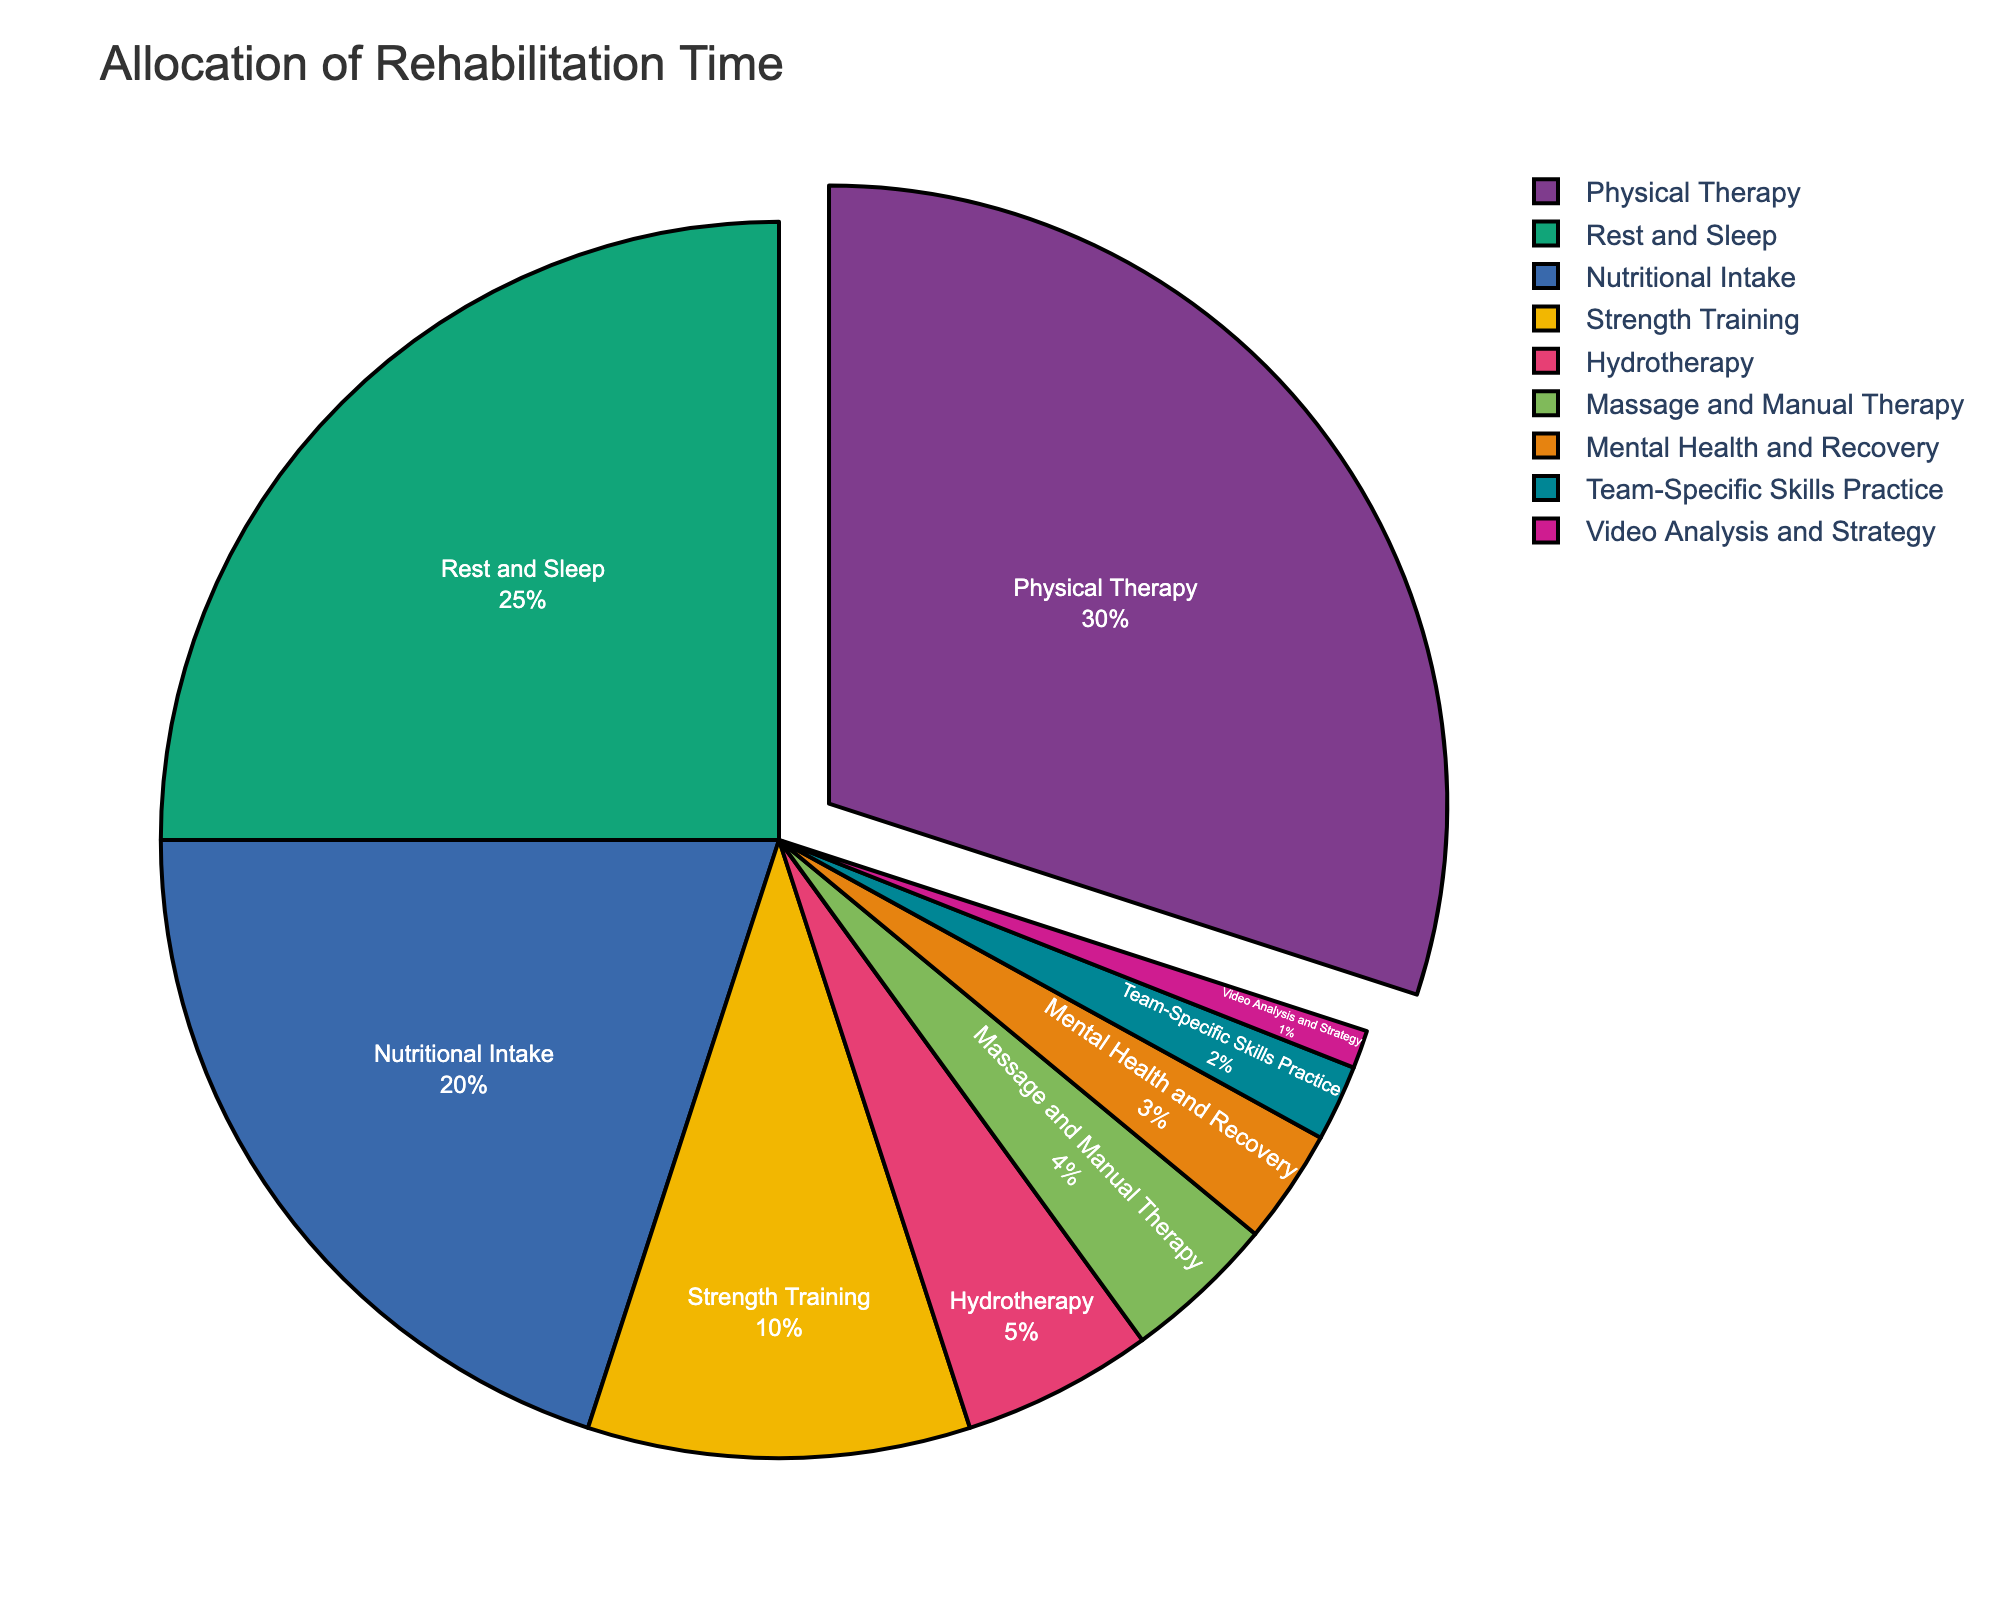How much more time is allocated to Physical Therapy compared to Strength Training? To determine how much more time is allocated to Physical Therapy compared to Strength Training, subtract the percentage for Strength Training from the percentage for Physical Therapy: 30% - 10% = 20%
Answer: 20% Which activity has the smallest allocation of rehabilitation time? To identify the activity with the smallest allocation of rehabilitation time, look for the activity with the smallest percentage in the pie chart. The smallest percentage is 1%, which corresponds to Video Analysis and Strategy.
Answer: Video Analysis and Strategy What percentage of the total rehabilitation time is dedicated to Rest and Sleep and Nutritional Intake combined? To find the combined percentage for Rest and Sleep and Nutritional Intake, add their individual percentages: 25% (Rest and Sleep) + 20% (Nutritional Intake) = 45%
Answer: 45% How does the time allocated to Hydrotherapy compare to that for Massage and Manual Therapy? To compare Hydrotherapy and Massage and Manual Therapy, look at their percentages in the pie chart: Hydrotherapy has 5%, and Massage and Manual Therapy has 4%. Hence, Hydrotherapy has a 1% higher allocation.
Answer: 1% higher What is the total percentage allocated to activities other than Physical Therapy, Rest and Sleep, and Nutritional Intake? To determine the total percentage for all other activities, subtract the sum of percentages for Physical Therapy, Rest and Sleep, and Nutritional Intake from 100%: 100% - (30% + 25% + 20%) = 25%
Answer: 25% How many times more is the percentage for Physical Therapy compared to Mental Health and Recovery? To find how many times more the percentage for Physical Therapy is compared to Mental Health and Recovery, divide the percentage for Physical Therapy by that for Mental Health and Recovery: 30% / 3% = 10 times
Answer: 10 times What is the difference in allocation time between the topmost and bottommost activities? To find the difference, subtract the percentage of the activity with the smallest allocation (Video Analysis and Strategy at 1%) from that with the largest (Physical Therapy at 30%): 30% - 1% = 29%
Answer: 29% What percentage of the rehabilitation time is dedicated to Mental Health and Recovery and Team-Specific Skills Practice together? To find the combined percentage for Mental Health and Recovery and Team-Specific Skills Practice, add their individual percentages: 3% (Mental Health and Recovery) + 2% (Team-Specific Skills Practice) = 5%
Answer: 5% Which two activities have a combined total allocation equal to that of Nutrition Intake? To find which two activities combined equal the percentage for Nutritional Intake (20%), we can see that Strength Training (10%) and Hydrotherapy (5%) combined with Mental Health and Recovery (3%) and Team-Specific Skills Practice (2%) add up to: 10% + 5% + 3% + 2% = 20%
Answer: Strength Training, Hydrotherapy, Mental Health and Recovery, Team-Specific Skills Practice (any two of these sum to 20%) 